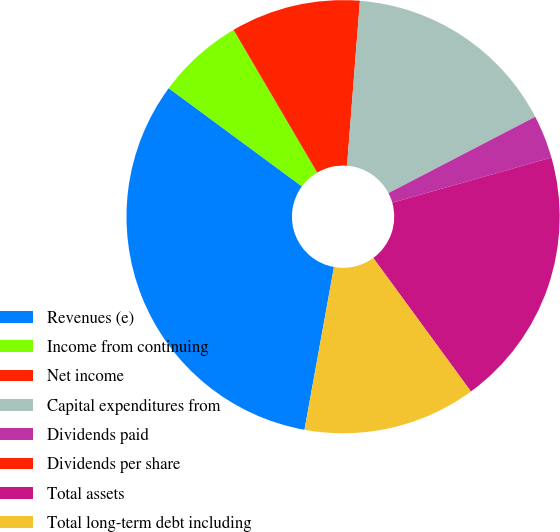<chart> <loc_0><loc_0><loc_500><loc_500><pie_chart><fcel>Revenues (e)<fcel>Income from continuing<fcel>Net income<fcel>Capital expenditures from<fcel>Dividends paid<fcel>Dividends per share<fcel>Total assets<fcel>Total long-term debt including<nl><fcel>32.26%<fcel>6.45%<fcel>9.68%<fcel>16.13%<fcel>3.23%<fcel>0.0%<fcel>19.35%<fcel>12.9%<nl></chart> 